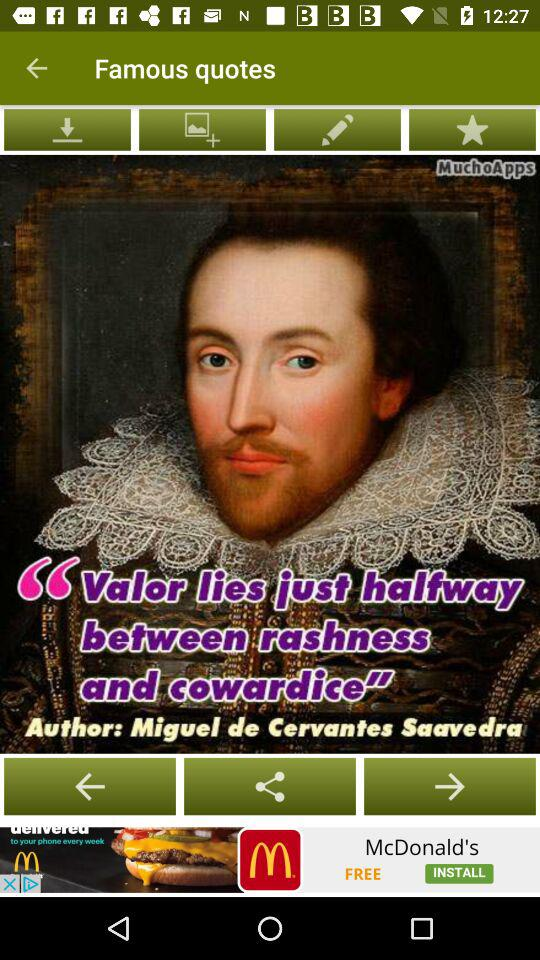What is the application name? The application name is "Famous quotes". 